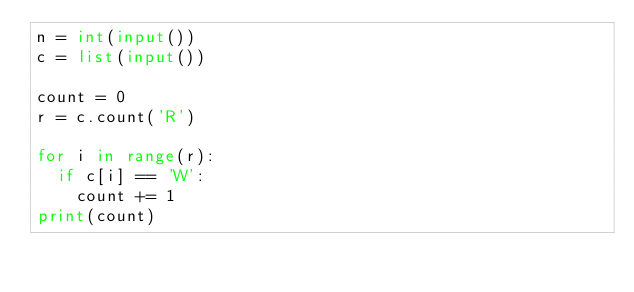Convert code to text. <code><loc_0><loc_0><loc_500><loc_500><_Python_>n = int(input())
c = list(input())

count = 0
r = c.count('R')

for i in range(r):
  if c[i] == 'W':
    count += 1
print(count)</code> 